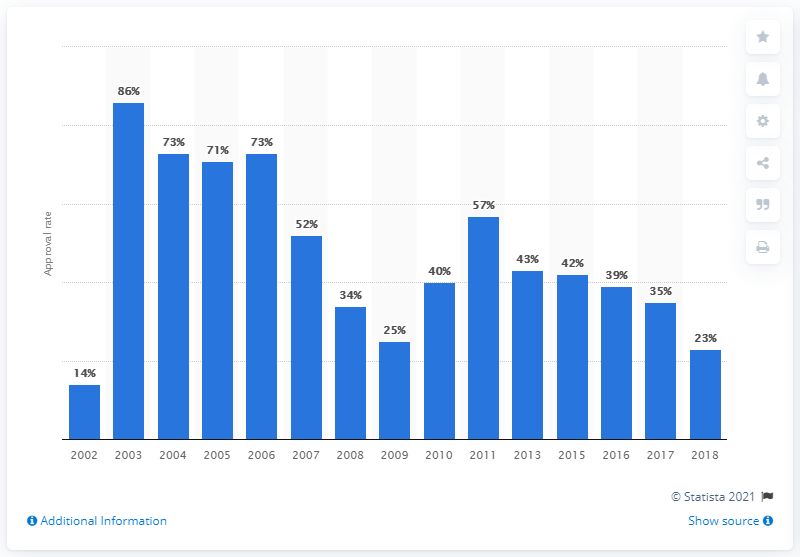Give some essential details in this illustration. The approval rate of Cristina Fernandez de Kirchner in 2009 was 25%. 